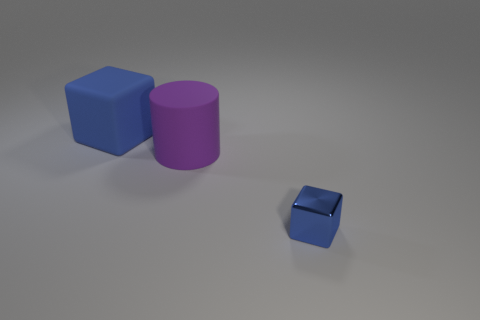Is there anything else that has the same size as the metallic block?
Ensure brevity in your answer.  No. Are there more big rubber objects that are on the right side of the big matte block than big blue metallic spheres?
Your answer should be very brief. Yes. There is a blue thing that is in front of the blue block that is to the left of the blue block that is to the right of the big cylinder; what shape is it?
Your response must be concise. Cube. There is a blue block behind the metal object; is it the same size as the small blue metal object?
Offer a very short reply. No. The object that is both in front of the large blue rubber block and behind the small metal block has what shape?
Ensure brevity in your answer.  Cylinder. Does the tiny thing have the same color as the big matte object behind the purple rubber cylinder?
Give a very brief answer. Yes. What color is the cube that is behind the blue thing in front of the matte object in front of the matte cube?
Ensure brevity in your answer.  Blue. There is another matte object that is the same shape as the small blue object; what is its color?
Your answer should be very brief. Blue. Is the number of large blue rubber things that are to the right of the blue metallic block the same as the number of big brown metallic cubes?
Ensure brevity in your answer.  Yes. How many spheres are purple objects or small things?
Ensure brevity in your answer.  0. 